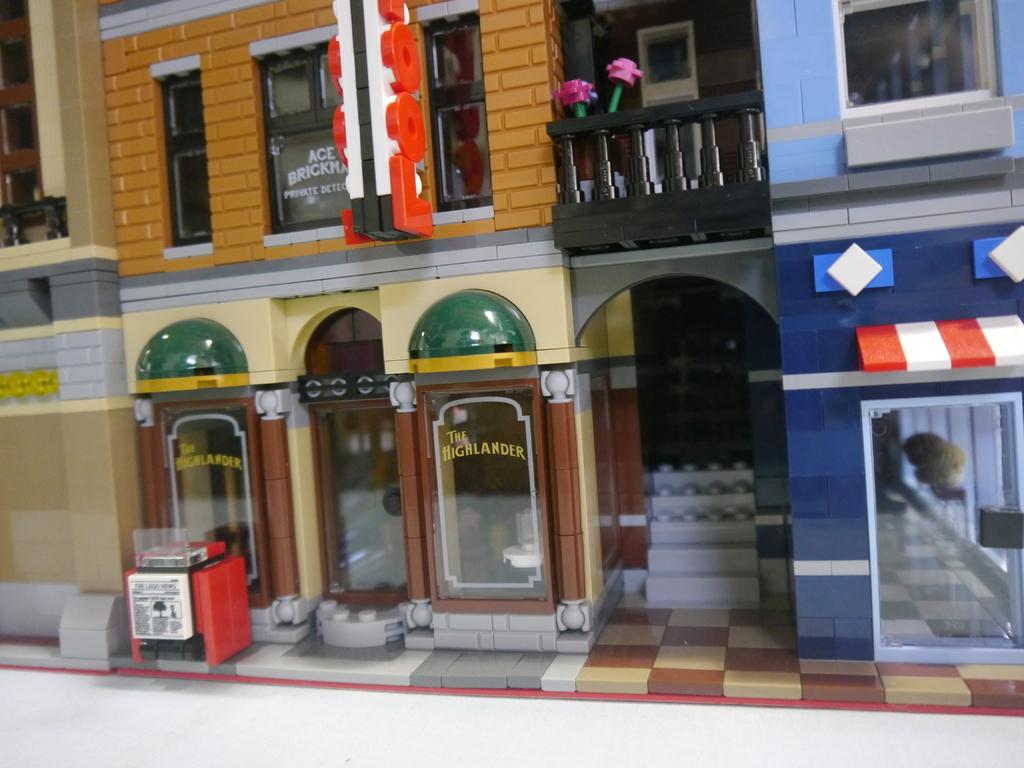<image>
Describe the image concisely. The outside of a pretend play store featuring the Highlander and Ace Brickman, private detector. . 